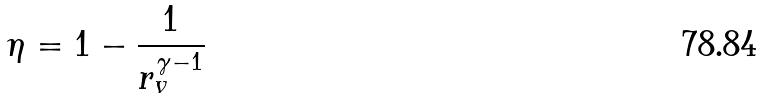Convert formula to latex. <formula><loc_0><loc_0><loc_500><loc_500>\eta = 1 - \frac { 1 } { r _ { v } ^ { \gamma - 1 } }</formula> 